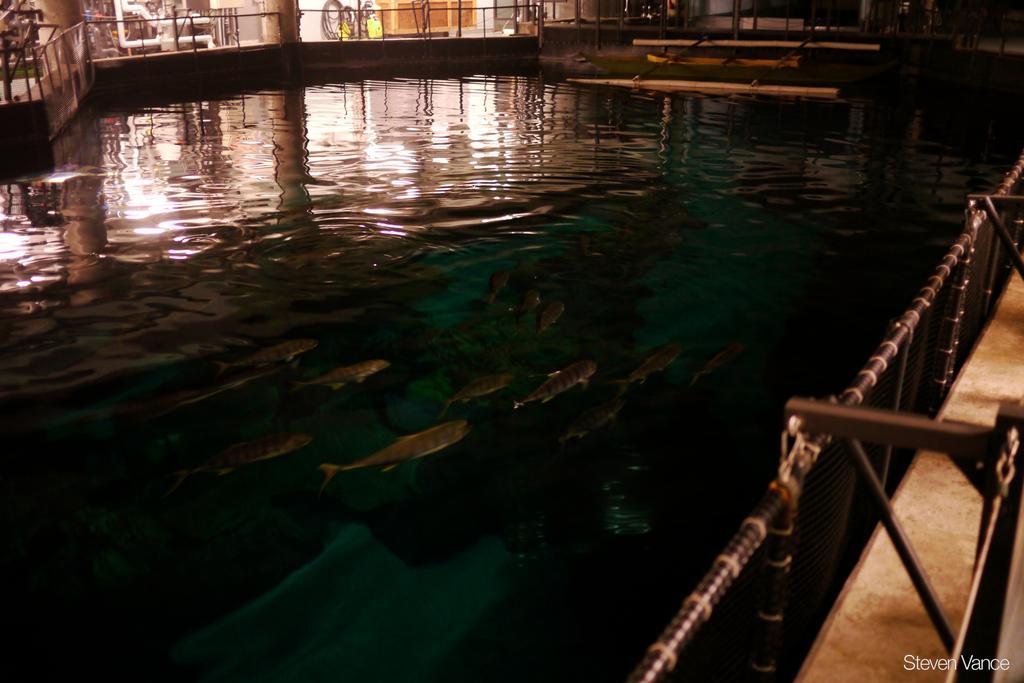Can you describe this image briefly? In this picture we can see few metal rods, fence and fishes in the water. 